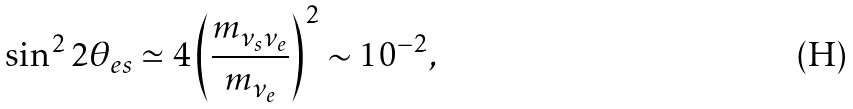<formula> <loc_0><loc_0><loc_500><loc_500>\sin ^ { 2 } 2 \theta _ { e s } \simeq 4 \left ( \frac { m _ { \nu _ { s } \nu _ { e } } } { m _ { \nu _ { e } } } \right ) ^ { 2 } \sim 1 0 ^ { - 2 } ,</formula> 